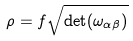Convert formula to latex. <formula><loc_0><loc_0><loc_500><loc_500>\rho = f \sqrt { \det ( \omega _ { \alpha \beta } ) }</formula> 